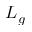<formula> <loc_0><loc_0><loc_500><loc_500>L _ { g }</formula> 